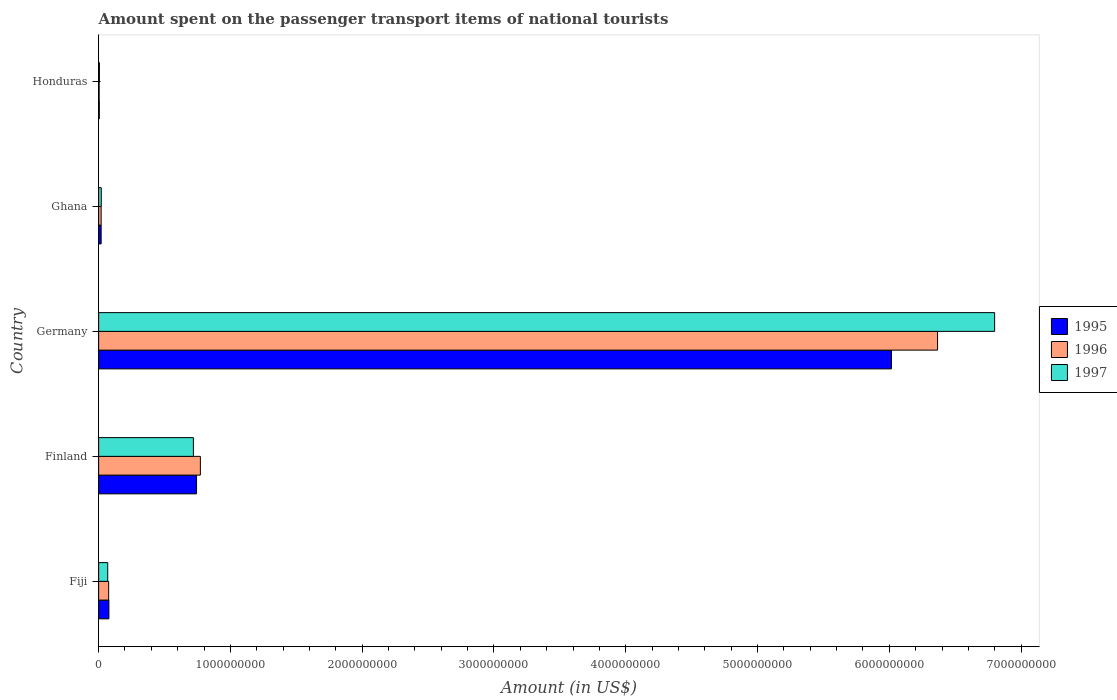How many groups of bars are there?
Provide a succinct answer. 5. Are the number of bars per tick equal to the number of legend labels?
Your answer should be compact. Yes. How many bars are there on the 2nd tick from the top?
Give a very brief answer. 3. In how many cases, is the number of bars for a given country not equal to the number of legend labels?
Offer a terse response. 0. What is the amount spent on the passenger transport items of national tourists in 1995 in Germany?
Ensure brevity in your answer.  6.02e+09. Across all countries, what is the maximum amount spent on the passenger transport items of national tourists in 1997?
Give a very brief answer. 6.80e+09. In which country was the amount spent on the passenger transport items of national tourists in 1997 minimum?
Offer a terse response. Honduras. What is the total amount spent on the passenger transport items of national tourists in 1996 in the graph?
Make the answer very short. 7.24e+09. What is the difference between the amount spent on the passenger transport items of national tourists in 1996 in Fiji and that in Finland?
Your response must be concise. -6.96e+08. What is the difference between the amount spent on the passenger transport items of national tourists in 1997 in Honduras and the amount spent on the passenger transport items of national tourists in 1996 in Ghana?
Your answer should be very brief. -1.30e+07. What is the average amount spent on the passenger transport items of national tourists in 1995 per country?
Offer a very short reply. 1.37e+09. What is the difference between the amount spent on the passenger transport items of national tourists in 1995 and amount spent on the passenger transport items of national tourists in 1997 in Finland?
Provide a short and direct response. 2.40e+07. In how many countries, is the amount spent on the passenger transport items of national tourists in 1997 greater than 2200000000 US$?
Give a very brief answer. 1. What is the ratio of the amount spent on the passenger transport items of national tourists in 1996 in Finland to that in Germany?
Make the answer very short. 0.12. Is the amount spent on the passenger transport items of national tourists in 1997 in Finland less than that in Honduras?
Make the answer very short. No. What is the difference between the highest and the second highest amount spent on the passenger transport items of national tourists in 1997?
Ensure brevity in your answer.  6.08e+09. What is the difference between the highest and the lowest amount spent on the passenger transport items of national tourists in 1997?
Provide a succinct answer. 6.79e+09. In how many countries, is the amount spent on the passenger transport items of national tourists in 1997 greater than the average amount spent on the passenger transport items of national tourists in 1997 taken over all countries?
Provide a short and direct response. 1. What does the 3rd bar from the top in Finland represents?
Make the answer very short. 1995. Is it the case that in every country, the sum of the amount spent on the passenger transport items of national tourists in 1996 and amount spent on the passenger transport items of national tourists in 1997 is greater than the amount spent on the passenger transport items of national tourists in 1995?
Give a very brief answer. Yes. How many bars are there?
Offer a very short reply. 15. Are all the bars in the graph horizontal?
Your response must be concise. Yes. What is the difference between two consecutive major ticks on the X-axis?
Ensure brevity in your answer.  1.00e+09. Does the graph contain any zero values?
Give a very brief answer. No. Where does the legend appear in the graph?
Ensure brevity in your answer.  Center right. How many legend labels are there?
Keep it short and to the point. 3. What is the title of the graph?
Your response must be concise. Amount spent on the passenger transport items of national tourists. What is the label or title of the Y-axis?
Offer a very short reply. Country. What is the Amount (in US$) of 1995 in Fiji?
Make the answer very short. 7.80e+07. What is the Amount (in US$) in 1996 in Fiji?
Your response must be concise. 7.60e+07. What is the Amount (in US$) of 1997 in Fiji?
Your response must be concise. 6.90e+07. What is the Amount (in US$) in 1995 in Finland?
Your answer should be very brief. 7.43e+08. What is the Amount (in US$) of 1996 in Finland?
Your response must be concise. 7.72e+08. What is the Amount (in US$) of 1997 in Finland?
Ensure brevity in your answer.  7.19e+08. What is the Amount (in US$) of 1995 in Germany?
Your answer should be very brief. 6.02e+09. What is the Amount (in US$) in 1996 in Germany?
Your answer should be compact. 6.37e+09. What is the Amount (in US$) in 1997 in Germany?
Provide a succinct answer. 6.80e+09. What is the Amount (in US$) of 1995 in Ghana?
Make the answer very short. 1.90e+07. What is the Amount (in US$) in 1996 in Ghana?
Your answer should be very brief. 1.90e+07. What is the Amount (in US$) in 1995 in Honduras?
Give a very brief answer. 5.00e+06. What is the Amount (in US$) in 1996 in Honduras?
Offer a terse response. 4.00e+06. What is the Amount (in US$) of 1997 in Honduras?
Offer a terse response. 6.00e+06. Across all countries, what is the maximum Amount (in US$) of 1995?
Provide a succinct answer. 6.02e+09. Across all countries, what is the maximum Amount (in US$) in 1996?
Provide a succinct answer. 6.37e+09. Across all countries, what is the maximum Amount (in US$) in 1997?
Offer a very short reply. 6.80e+09. Across all countries, what is the minimum Amount (in US$) of 1995?
Offer a very short reply. 5.00e+06. What is the total Amount (in US$) in 1995 in the graph?
Offer a very short reply. 6.86e+09. What is the total Amount (in US$) in 1996 in the graph?
Provide a succinct answer. 7.24e+09. What is the total Amount (in US$) in 1997 in the graph?
Keep it short and to the point. 7.61e+09. What is the difference between the Amount (in US$) in 1995 in Fiji and that in Finland?
Offer a very short reply. -6.65e+08. What is the difference between the Amount (in US$) in 1996 in Fiji and that in Finland?
Ensure brevity in your answer.  -6.96e+08. What is the difference between the Amount (in US$) in 1997 in Fiji and that in Finland?
Your answer should be very brief. -6.50e+08. What is the difference between the Amount (in US$) in 1995 in Fiji and that in Germany?
Give a very brief answer. -5.94e+09. What is the difference between the Amount (in US$) in 1996 in Fiji and that in Germany?
Ensure brevity in your answer.  -6.29e+09. What is the difference between the Amount (in US$) in 1997 in Fiji and that in Germany?
Your answer should be compact. -6.73e+09. What is the difference between the Amount (in US$) in 1995 in Fiji and that in Ghana?
Keep it short and to the point. 5.90e+07. What is the difference between the Amount (in US$) in 1996 in Fiji and that in Ghana?
Offer a terse response. 5.70e+07. What is the difference between the Amount (in US$) in 1997 in Fiji and that in Ghana?
Offer a terse response. 4.90e+07. What is the difference between the Amount (in US$) of 1995 in Fiji and that in Honduras?
Offer a terse response. 7.30e+07. What is the difference between the Amount (in US$) of 1996 in Fiji and that in Honduras?
Provide a short and direct response. 7.20e+07. What is the difference between the Amount (in US$) in 1997 in Fiji and that in Honduras?
Your answer should be very brief. 6.30e+07. What is the difference between the Amount (in US$) of 1995 in Finland and that in Germany?
Offer a very short reply. -5.27e+09. What is the difference between the Amount (in US$) in 1996 in Finland and that in Germany?
Ensure brevity in your answer.  -5.59e+09. What is the difference between the Amount (in US$) of 1997 in Finland and that in Germany?
Make the answer very short. -6.08e+09. What is the difference between the Amount (in US$) in 1995 in Finland and that in Ghana?
Give a very brief answer. 7.24e+08. What is the difference between the Amount (in US$) in 1996 in Finland and that in Ghana?
Make the answer very short. 7.53e+08. What is the difference between the Amount (in US$) of 1997 in Finland and that in Ghana?
Ensure brevity in your answer.  6.99e+08. What is the difference between the Amount (in US$) in 1995 in Finland and that in Honduras?
Your response must be concise. 7.38e+08. What is the difference between the Amount (in US$) in 1996 in Finland and that in Honduras?
Offer a very short reply. 7.68e+08. What is the difference between the Amount (in US$) in 1997 in Finland and that in Honduras?
Offer a very short reply. 7.13e+08. What is the difference between the Amount (in US$) of 1995 in Germany and that in Ghana?
Provide a short and direct response. 6.00e+09. What is the difference between the Amount (in US$) of 1996 in Germany and that in Ghana?
Ensure brevity in your answer.  6.35e+09. What is the difference between the Amount (in US$) in 1997 in Germany and that in Ghana?
Make the answer very short. 6.78e+09. What is the difference between the Amount (in US$) in 1995 in Germany and that in Honduras?
Offer a terse response. 6.01e+09. What is the difference between the Amount (in US$) in 1996 in Germany and that in Honduras?
Offer a terse response. 6.36e+09. What is the difference between the Amount (in US$) in 1997 in Germany and that in Honduras?
Provide a succinct answer. 6.79e+09. What is the difference between the Amount (in US$) of 1995 in Ghana and that in Honduras?
Your answer should be very brief. 1.40e+07. What is the difference between the Amount (in US$) of 1996 in Ghana and that in Honduras?
Provide a short and direct response. 1.50e+07. What is the difference between the Amount (in US$) of 1997 in Ghana and that in Honduras?
Provide a succinct answer. 1.40e+07. What is the difference between the Amount (in US$) of 1995 in Fiji and the Amount (in US$) of 1996 in Finland?
Give a very brief answer. -6.94e+08. What is the difference between the Amount (in US$) of 1995 in Fiji and the Amount (in US$) of 1997 in Finland?
Offer a terse response. -6.41e+08. What is the difference between the Amount (in US$) of 1996 in Fiji and the Amount (in US$) of 1997 in Finland?
Provide a short and direct response. -6.43e+08. What is the difference between the Amount (in US$) of 1995 in Fiji and the Amount (in US$) of 1996 in Germany?
Your answer should be very brief. -6.29e+09. What is the difference between the Amount (in US$) of 1995 in Fiji and the Amount (in US$) of 1997 in Germany?
Your answer should be very brief. -6.72e+09. What is the difference between the Amount (in US$) in 1996 in Fiji and the Amount (in US$) in 1997 in Germany?
Provide a short and direct response. -6.72e+09. What is the difference between the Amount (in US$) in 1995 in Fiji and the Amount (in US$) in 1996 in Ghana?
Offer a terse response. 5.90e+07. What is the difference between the Amount (in US$) of 1995 in Fiji and the Amount (in US$) of 1997 in Ghana?
Provide a succinct answer. 5.80e+07. What is the difference between the Amount (in US$) of 1996 in Fiji and the Amount (in US$) of 1997 in Ghana?
Offer a very short reply. 5.60e+07. What is the difference between the Amount (in US$) in 1995 in Fiji and the Amount (in US$) in 1996 in Honduras?
Your answer should be compact. 7.40e+07. What is the difference between the Amount (in US$) in 1995 in Fiji and the Amount (in US$) in 1997 in Honduras?
Offer a very short reply. 7.20e+07. What is the difference between the Amount (in US$) of 1996 in Fiji and the Amount (in US$) of 1997 in Honduras?
Provide a short and direct response. 7.00e+07. What is the difference between the Amount (in US$) of 1995 in Finland and the Amount (in US$) of 1996 in Germany?
Your response must be concise. -5.62e+09. What is the difference between the Amount (in US$) in 1995 in Finland and the Amount (in US$) in 1997 in Germany?
Give a very brief answer. -6.06e+09. What is the difference between the Amount (in US$) in 1996 in Finland and the Amount (in US$) in 1997 in Germany?
Keep it short and to the point. -6.03e+09. What is the difference between the Amount (in US$) in 1995 in Finland and the Amount (in US$) in 1996 in Ghana?
Provide a short and direct response. 7.24e+08. What is the difference between the Amount (in US$) in 1995 in Finland and the Amount (in US$) in 1997 in Ghana?
Make the answer very short. 7.23e+08. What is the difference between the Amount (in US$) in 1996 in Finland and the Amount (in US$) in 1997 in Ghana?
Give a very brief answer. 7.52e+08. What is the difference between the Amount (in US$) in 1995 in Finland and the Amount (in US$) in 1996 in Honduras?
Make the answer very short. 7.39e+08. What is the difference between the Amount (in US$) of 1995 in Finland and the Amount (in US$) of 1997 in Honduras?
Give a very brief answer. 7.37e+08. What is the difference between the Amount (in US$) in 1996 in Finland and the Amount (in US$) in 1997 in Honduras?
Your answer should be very brief. 7.66e+08. What is the difference between the Amount (in US$) in 1995 in Germany and the Amount (in US$) in 1996 in Ghana?
Provide a short and direct response. 6.00e+09. What is the difference between the Amount (in US$) of 1995 in Germany and the Amount (in US$) of 1997 in Ghana?
Your answer should be compact. 6.00e+09. What is the difference between the Amount (in US$) in 1996 in Germany and the Amount (in US$) in 1997 in Ghana?
Your answer should be compact. 6.35e+09. What is the difference between the Amount (in US$) of 1995 in Germany and the Amount (in US$) of 1996 in Honduras?
Your response must be concise. 6.01e+09. What is the difference between the Amount (in US$) in 1995 in Germany and the Amount (in US$) in 1997 in Honduras?
Your response must be concise. 6.01e+09. What is the difference between the Amount (in US$) in 1996 in Germany and the Amount (in US$) in 1997 in Honduras?
Your answer should be very brief. 6.36e+09. What is the difference between the Amount (in US$) of 1995 in Ghana and the Amount (in US$) of 1996 in Honduras?
Ensure brevity in your answer.  1.50e+07. What is the difference between the Amount (in US$) of 1995 in Ghana and the Amount (in US$) of 1997 in Honduras?
Make the answer very short. 1.30e+07. What is the difference between the Amount (in US$) of 1996 in Ghana and the Amount (in US$) of 1997 in Honduras?
Offer a terse response. 1.30e+07. What is the average Amount (in US$) in 1995 per country?
Provide a short and direct response. 1.37e+09. What is the average Amount (in US$) of 1996 per country?
Provide a succinct answer. 1.45e+09. What is the average Amount (in US$) of 1997 per country?
Your answer should be very brief. 1.52e+09. What is the difference between the Amount (in US$) in 1995 and Amount (in US$) in 1996 in Fiji?
Provide a succinct answer. 2.00e+06. What is the difference between the Amount (in US$) of 1995 and Amount (in US$) of 1997 in Fiji?
Provide a succinct answer. 9.00e+06. What is the difference between the Amount (in US$) of 1996 and Amount (in US$) of 1997 in Fiji?
Offer a very short reply. 7.00e+06. What is the difference between the Amount (in US$) of 1995 and Amount (in US$) of 1996 in Finland?
Offer a very short reply. -2.90e+07. What is the difference between the Amount (in US$) in 1995 and Amount (in US$) in 1997 in Finland?
Offer a terse response. 2.40e+07. What is the difference between the Amount (in US$) in 1996 and Amount (in US$) in 1997 in Finland?
Offer a very short reply. 5.30e+07. What is the difference between the Amount (in US$) in 1995 and Amount (in US$) in 1996 in Germany?
Keep it short and to the point. -3.50e+08. What is the difference between the Amount (in US$) of 1995 and Amount (in US$) of 1997 in Germany?
Keep it short and to the point. -7.83e+08. What is the difference between the Amount (in US$) in 1996 and Amount (in US$) in 1997 in Germany?
Your answer should be compact. -4.33e+08. What is the difference between the Amount (in US$) of 1995 and Amount (in US$) of 1996 in Honduras?
Offer a very short reply. 1.00e+06. What is the ratio of the Amount (in US$) in 1995 in Fiji to that in Finland?
Provide a short and direct response. 0.1. What is the ratio of the Amount (in US$) of 1996 in Fiji to that in Finland?
Your response must be concise. 0.1. What is the ratio of the Amount (in US$) in 1997 in Fiji to that in Finland?
Offer a very short reply. 0.1. What is the ratio of the Amount (in US$) of 1995 in Fiji to that in Germany?
Provide a short and direct response. 0.01. What is the ratio of the Amount (in US$) of 1996 in Fiji to that in Germany?
Your answer should be compact. 0.01. What is the ratio of the Amount (in US$) in 1997 in Fiji to that in Germany?
Provide a short and direct response. 0.01. What is the ratio of the Amount (in US$) in 1995 in Fiji to that in Ghana?
Your answer should be very brief. 4.11. What is the ratio of the Amount (in US$) in 1997 in Fiji to that in Ghana?
Keep it short and to the point. 3.45. What is the ratio of the Amount (in US$) in 1995 in Fiji to that in Honduras?
Keep it short and to the point. 15.6. What is the ratio of the Amount (in US$) in 1997 in Fiji to that in Honduras?
Make the answer very short. 11.5. What is the ratio of the Amount (in US$) in 1995 in Finland to that in Germany?
Provide a short and direct response. 0.12. What is the ratio of the Amount (in US$) in 1996 in Finland to that in Germany?
Provide a short and direct response. 0.12. What is the ratio of the Amount (in US$) of 1997 in Finland to that in Germany?
Provide a succinct answer. 0.11. What is the ratio of the Amount (in US$) in 1995 in Finland to that in Ghana?
Make the answer very short. 39.11. What is the ratio of the Amount (in US$) of 1996 in Finland to that in Ghana?
Your answer should be compact. 40.63. What is the ratio of the Amount (in US$) of 1997 in Finland to that in Ghana?
Keep it short and to the point. 35.95. What is the ratio of the Amount (in US$) in 1995 in Finland to that in Honduras?
Provide a succinct answer. 148.6. What is the ratio of the Amount (in US$) in 1996 in Finland to that in Honduras?
Offer a terse response. 193. What is the ratio of the Amount (in US$) in 1997 in Finland to that in Honduras?
Keep it short and to the point. 119.83. What is the ratio of the Amount (in US$) in 1995 in Germany to that in Ghana?
Make the answer very short. 316.63. What is the ratio of the Amount (in US$) in 1996 in Germany to that in Ghana?
Keep it short and to the point. 335.05. What is the ratio of the Amount (in US$) of 1997 in Germany to that in Ghana?
Ensure brevity in your answer.  339.95. What is the ratio of the Amount (in US$) of 1995 in Germany to that in Honduras?
Ensure brevity in your answer.  1203.2. What is the ratio of the Amount (in US$) in 1996 in Germany to that in Honduras?
Provide a succinct answer. 1591.5. What is the ratio of the Amount (in US$) in 1997 in Germany to that in Honduras?
Keep it short and to the point. 1133.17. What is the ratio of the Amount (in US$) in 1996 in Ghana to that in Honduras?
Your answer should be very brief. 4.75. What is the ratio of the Amount (in US$) of 1997 in Ghana to that in Honduras?
Provide a short and direct response. 3.33. What is the difference between the highest and the second highest Amount (in US$) of 1995?
Keep it short and to the point. 5.27e+09. What is the difference between the highest and the second highest Amount (in US$) in 1996?
Offer a terse response. 5.59e+09. What is the difference between the highest and the second highest Amount (in US$) of 1997?
Your response must be concise. 6.08e+09. What is the difference between the highest and the lowest Amount (in US$) of 1995?
Offer a very short reply. 6.01e+09. What is the difference between the highest and the lowest Amount (in US$) of 1996?
Your answer should be compact. 6.36e+09. What is the difference between the highest and the lowest Amount (in US$) in 1997?
Keep it short and to the point. 6.79e+09. 